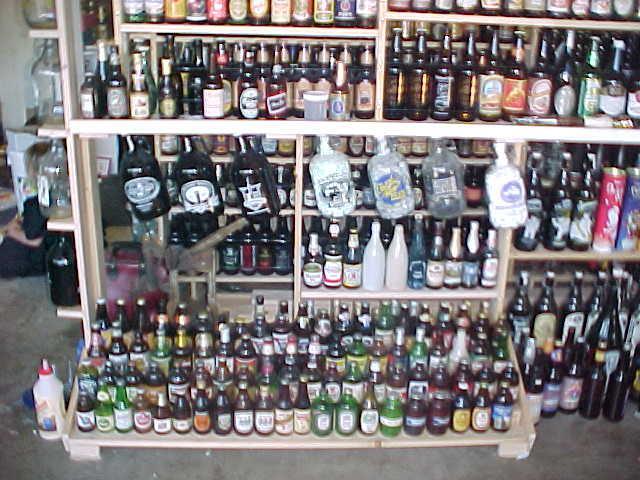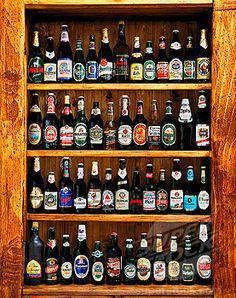The first image is the image on the left, the second image is the image on the right. Evaluate the accuracy of this statement regarding the images: "The bottles in one of the images do not have caps.". Is it true? Answer yes or no. No. 